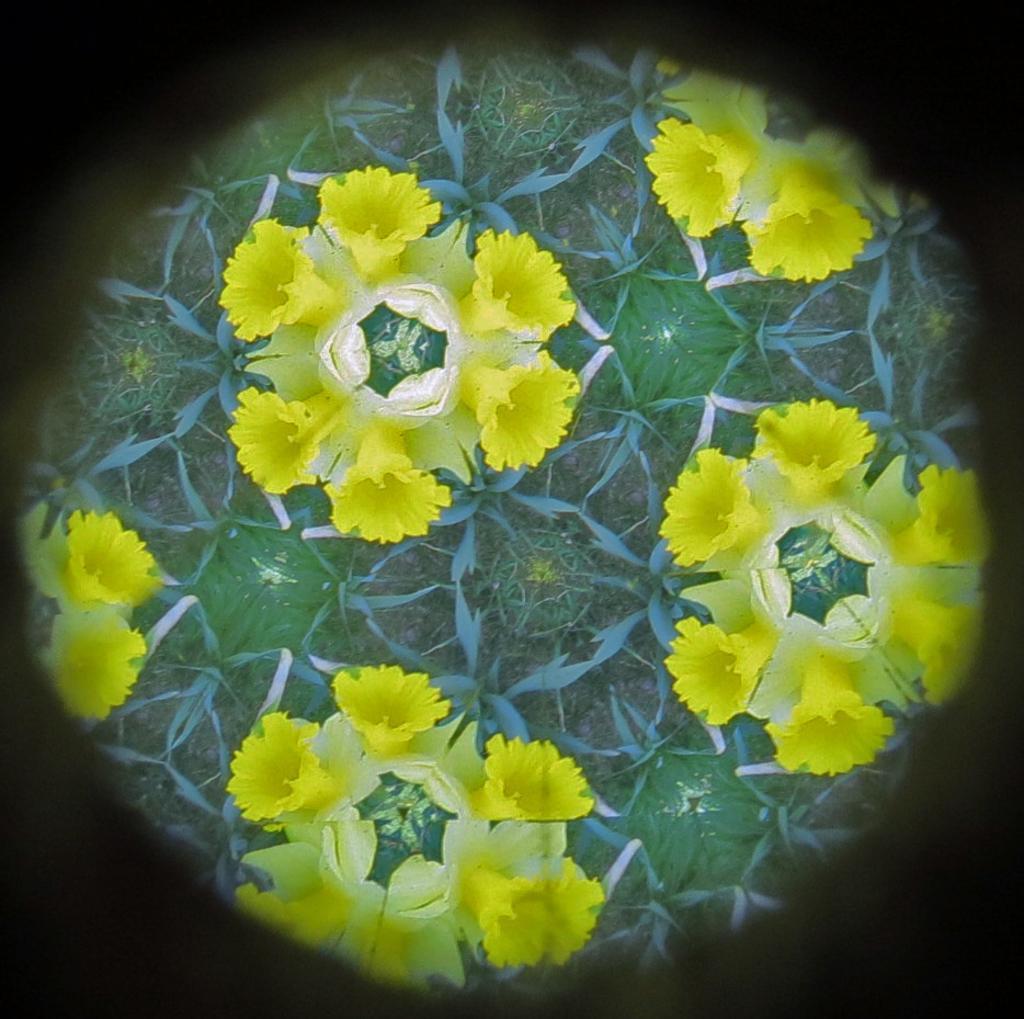Could you give a brief overview of what you see in this image? In this image we can see yellow color flowers and green color leaves. 